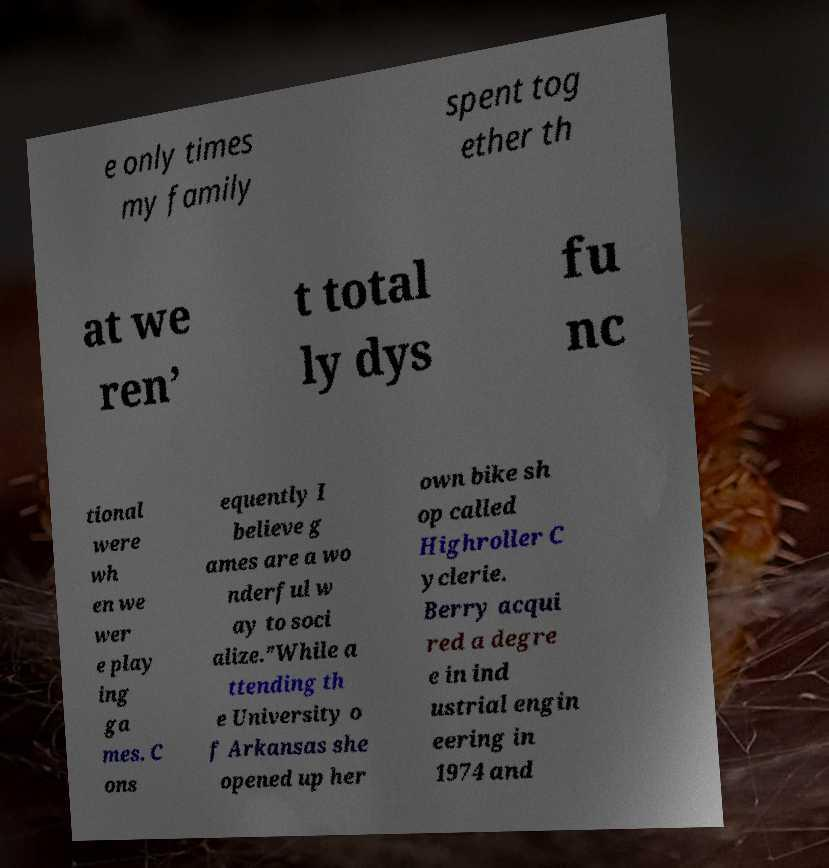Can you read and provide the text displayed in the image?This photo seems to have some interesting text. Can you extract and type it out for me? e only times my family spent tog ether th at we ren’ t total ly dys fu nc tional were wh en we wer e play ing ga mes. C ons equently I believe g ames are a wo nderful w ay to soci alize.”While a ttending th e University o f Arkansas she opened up her own bike sh op called Highroller C yclerie. Berry acqui red a degre e in ind ustrial engin eering in 1974 and 